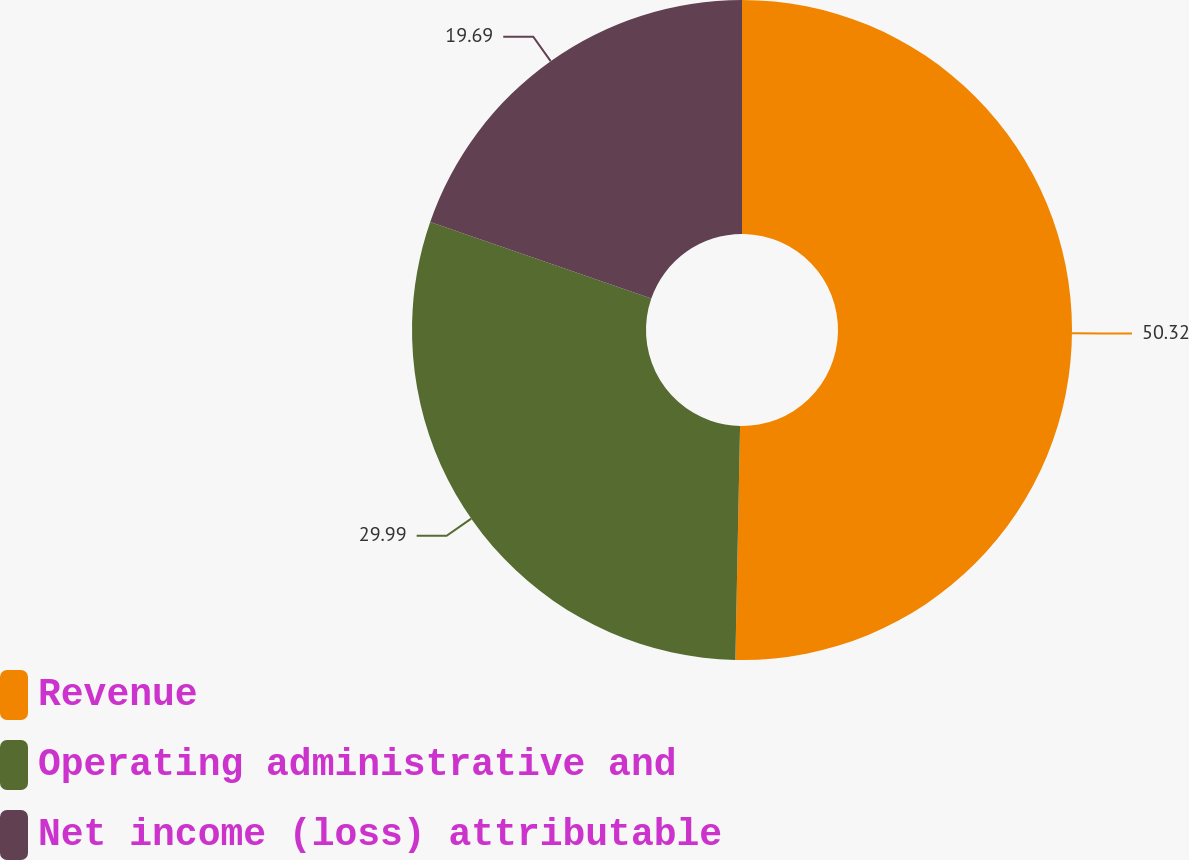Convert chart to OTSL. <chart><loc_0><loc_0><loc_500><loc_500><pie_chart><fcel>Revenue<fcel>Operating administrative and<fcel>Net income (loss) attributable<nl><fcel>50.32%<fcel>29.99%<fcel>19.69%<nl></chart> 